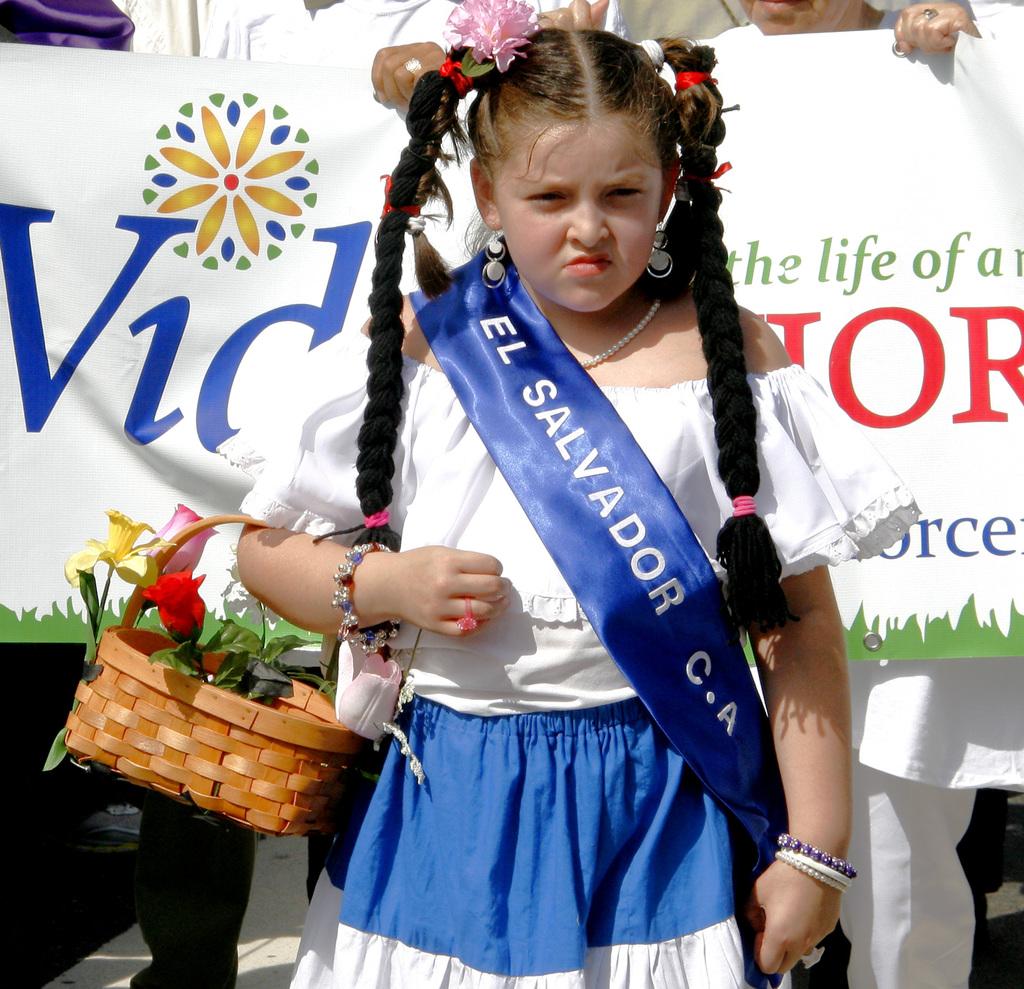What country is on the sash?
Give a very brief answer. El salvador. 